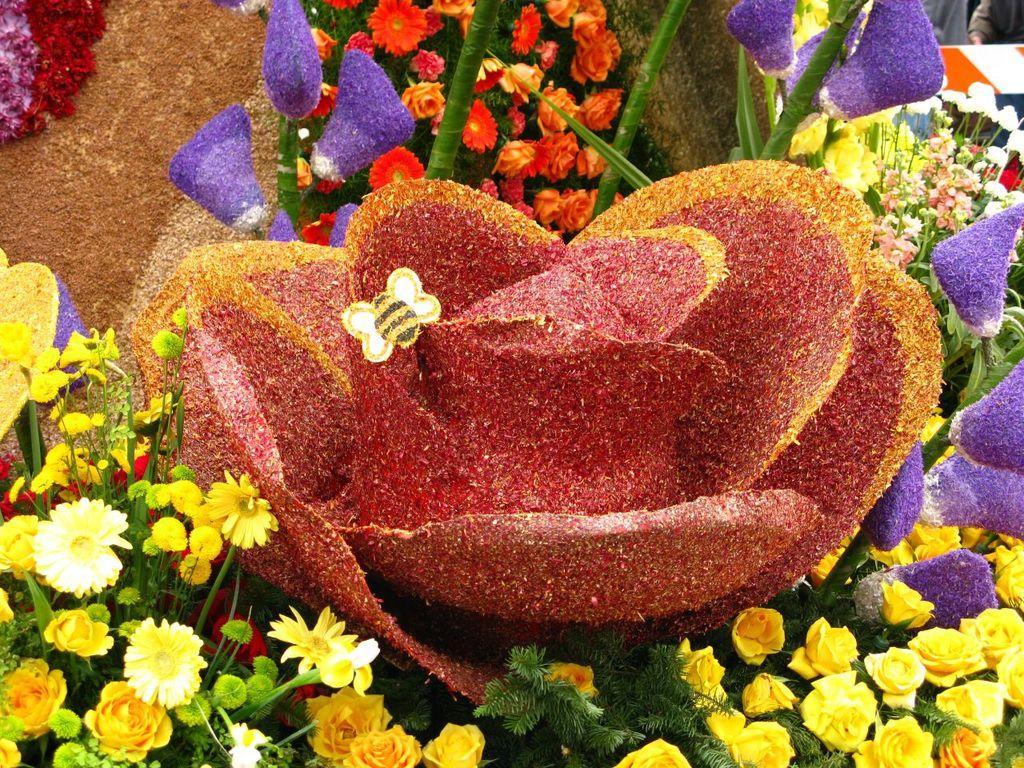In one or two sentences, can you explain what this image depicts? There are many colorful flowers. 